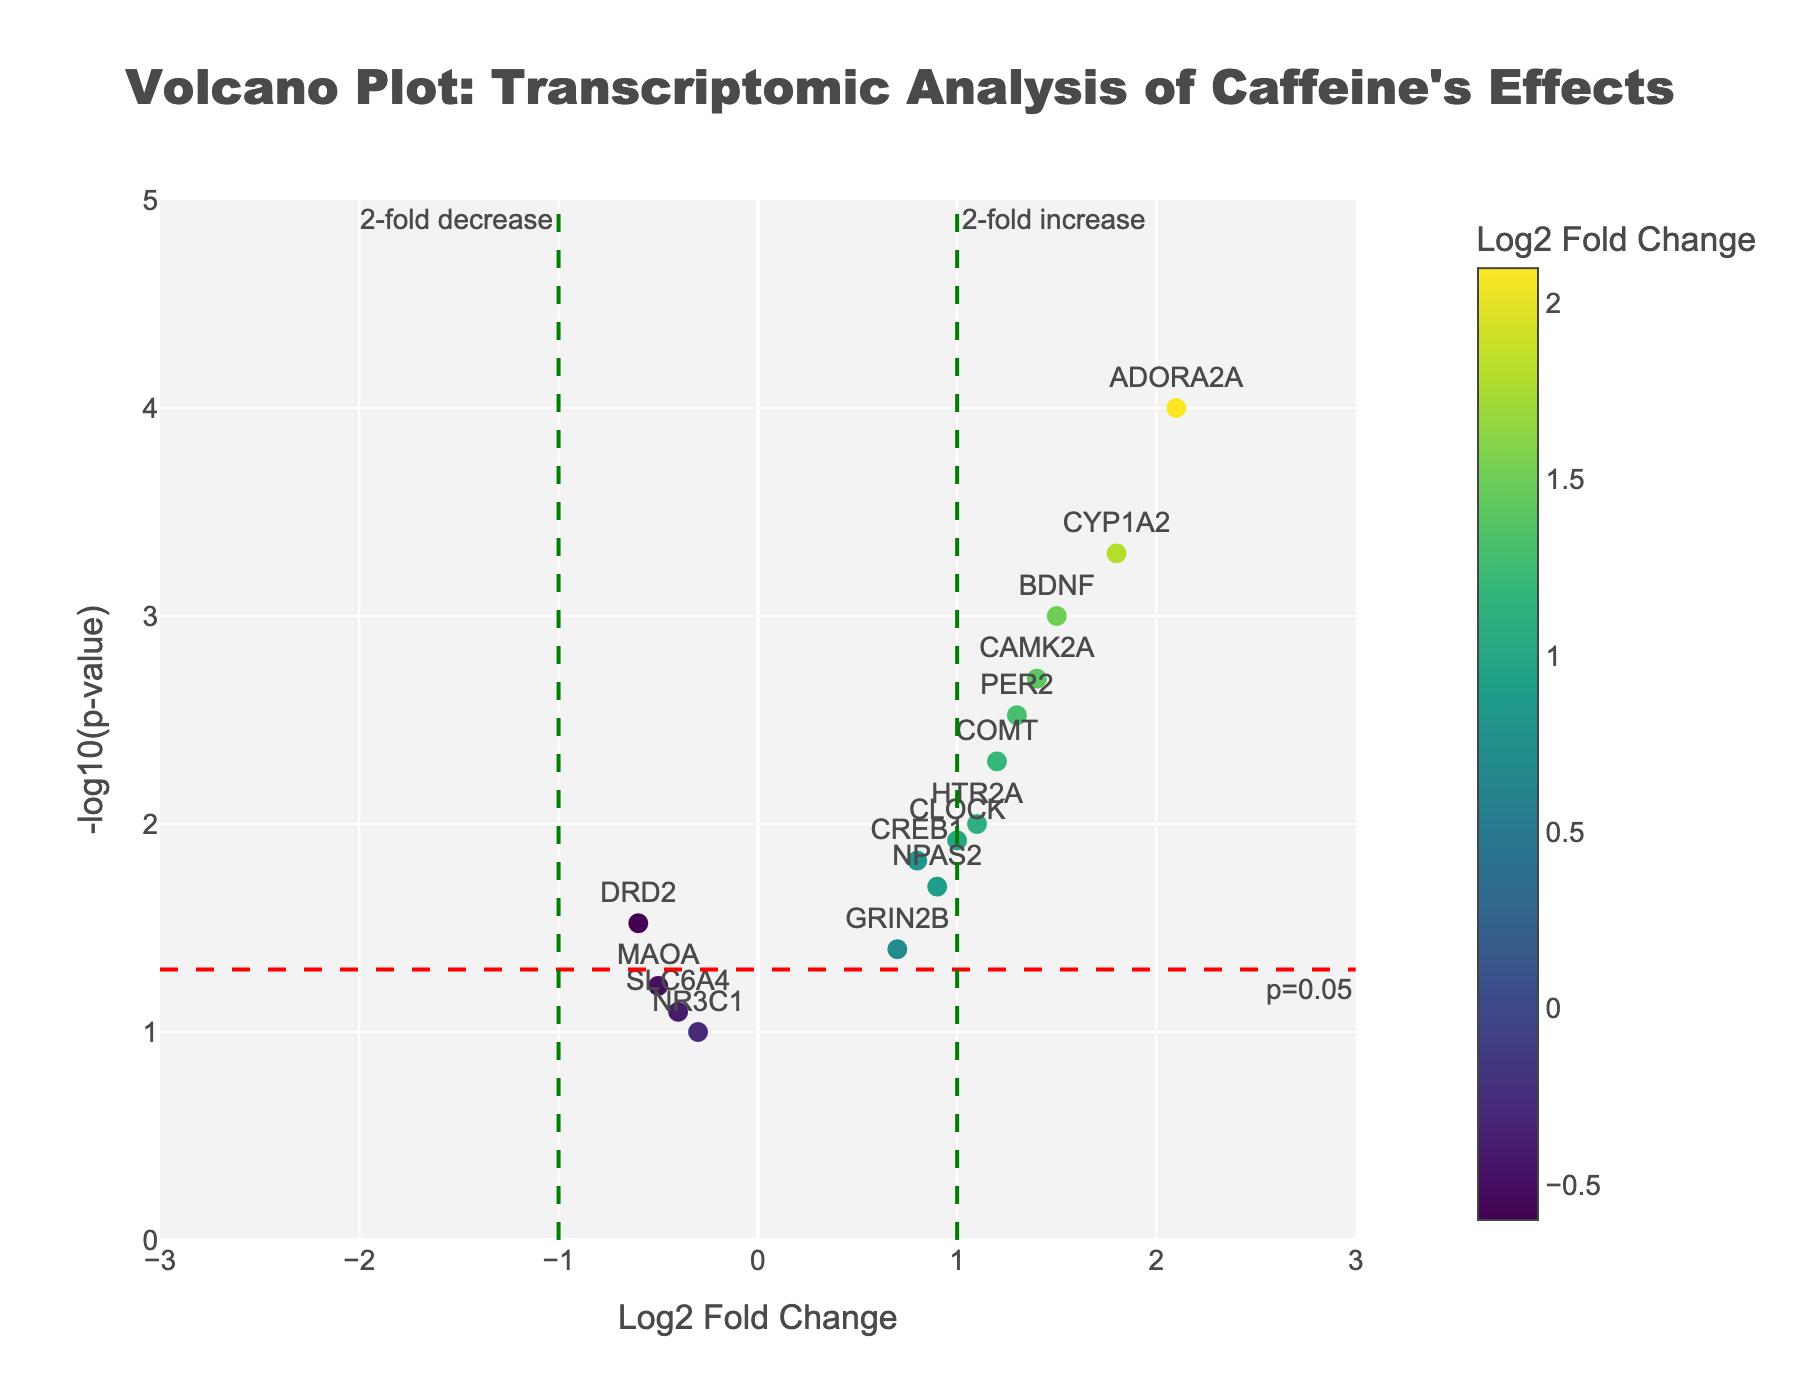What is the title of the plot? The title is positioned at the top center of the plot and is in large, bold text. It reads "Volcano Plot: Transcriptomic Analysis of Caffeine's Effects."
Answer: "Volcano Plot: Transcriptomic Analysis of Caffeine's Effects" How many genes have a Log2 Fold Change greater than 1? To determine this, count the points on the plot located to the right of the vertical green line at Log2 Fold Change = 1. These genes are ADORA2A, CYP1A2, CAMK2A, and BDNF. So there are 4 genes.
Answer: 4 Which gene has the highest -log10(p-value) and what is its value? The gene ADORA2A is the highest positioned point on the plot, indicating the highest -log10(p-value). The y-coordinate (value) is approximately 4.
Answer: ADORA2A, 4 Are there any genes with a Log2 Fold Change of less than -1? Look for data points located to the left of the vertical green line at Log2 Fold Change = -1. There are no such points, indicating no genes with a Log2 Fold Change of less than -1.
Answer: No What is the p-value for the gene COMT? The hovertext for the gene COMT provides its p-value, which is 0.005.
Answer: 0.005 How many genes are above the significance threshold of p-value = 0.05? Determine this by counting the points above the horizontal red dashed line that represents -log10(0.05). There are 10 genes: BDNF, CREB1, COMT, ADORA2A, NPAS2, PER2, CYP1A2, HTR2A, CLOCK, and CAMK2A.
Answer: 10 Which genes show a fold change greater than 2-fold increase? Points to the right of the Log2 Fold Change = 1 line and above the p-value significance line represent more than 2-fold increase. These genes are ADORA2A and CYP1A2.
Answer: ADORA2A, CYP1A2 Compare the Log2 Fold Change of BDNF and CREB1. Which is higher and by how much? BDNF has a Log2 Fold Change of 1.5 and CREB1 has 0.8. The difference is 1.5 - 0.8 = 0.7. BDNF is higher by 0.7.
Answer: BDNF is higher by 0.7 Which gene has the closest p-value to the threshold of 0.05 but still significant? MAOA has a p-value of 0.06, which is close to the threshold but not significant. The significant gene closest to the threshold is GRIN2B with a p-value of 0.04.
Answer: GRIN2B For the gene with the Log2 Fold Change closest to zero, provide its name and p-value. SLC6A4 shows a Log2 Fold Change of -0.4, which is closest to zero compared to other genes. Its p-value is 0.08.
Answer: SLC6A4, 0.08 